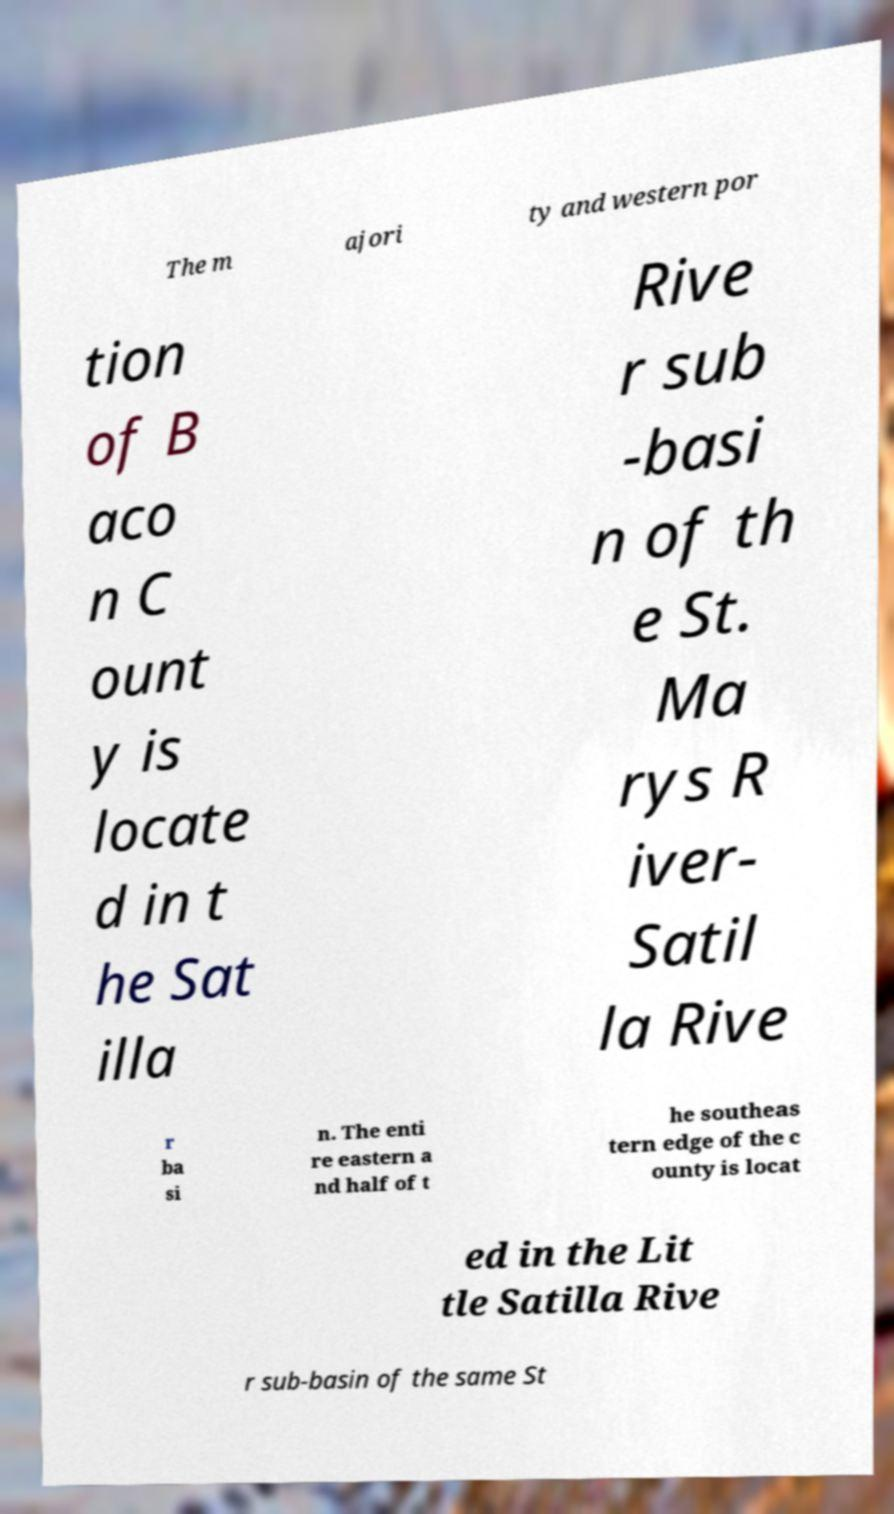For documentation purposes, I need the text within this image transcribed. Could you provide that? The m ajori ty and western por tion of B aco n C ount y is locate d in t he Sat illa Rive r sub -basi n of th e St. Ma rys R iver- Satil la Rive r ba si n. The enti re eastern a nd half of t he southeas tern edge of the c ounty is locat ed in the Lit tle Satilla Rive r sub-basin of the same St 